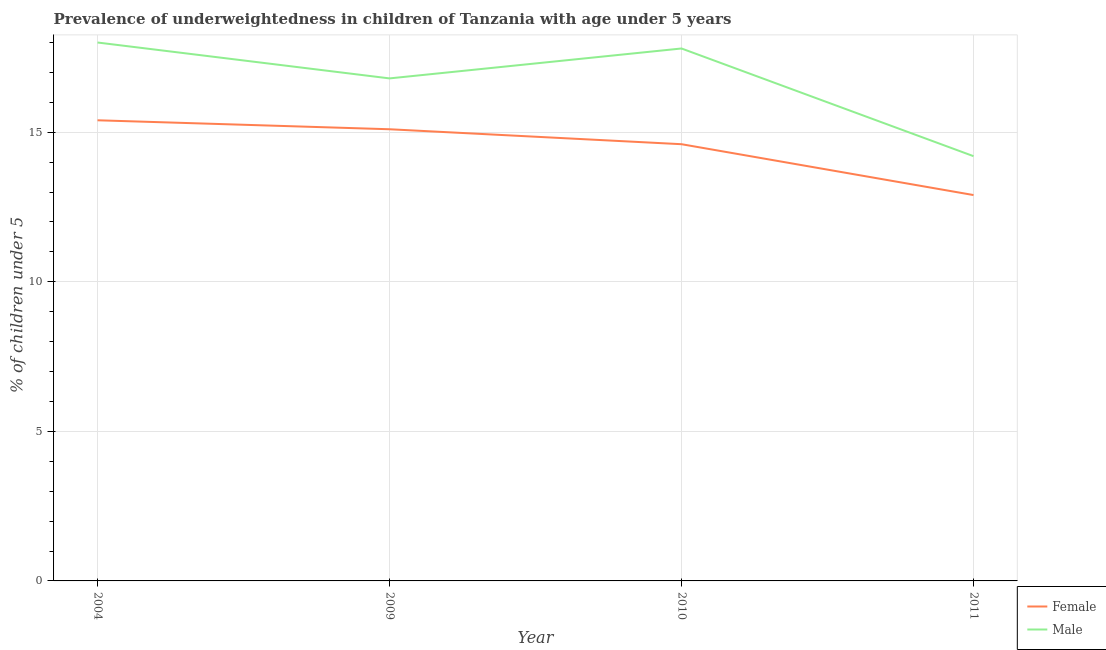How many different coloured lines are there?
Give a very brief answer. 2. What is the percentage of underweighted female children in 2009?
Your answer should be compact. 15.1. Across all years, what is the maximum percentage of underweighted female children?
Ensure brevity in your answer.  15.4. Across all years, what is the minimum percentage of underweighted female children?
Offer a very short reply. 12.9. What is the total percentage of underweighted male children in the graph?
Your answer should be compact. 66.8. What is the difference between the percentage of underweighted male children in 2004 and that in 2011?
Provide a short and direct response. 3.8. What is the difference between the percentage of underweighted male children in 2011 and the percentage of underweighted female children in 2010?
Make the answer very short. -0.4. What is the average percentage of underweighted male children per year?
Make the answer very short. 16.7. In the year 2004, what is the difference between the percentage of underweighted female children and percentage of underweighted male children?
Your response must be concise. -2.6. What is the ratio of the percentage of underweighted male children in 2004 to that in 2010?
Give a very brief answer. 1.01. What is the difference between the highest and the second highest percentage of underweighted female children?
Offer a very short reply. 0.3. What is the difference between the highest and the lowest percentage of underweighted male children?
Ensure brevity in your answer.  3.8. Is the percentage of underweighted female children strictly greater than the percentage of underweighted male children over the years?
Your response must be concise. No. Is the percentage of underweighted male children strictly less than the percentage of underweighted female children over the years?
Give a very brief answer. No. What is the difference between two consecutive major ticks on the Y-axis?
Keep it short and to the point. 5. Does the graph contain grids?
Your answer should be very brief. Yes. Where does the legend appear in the graph?
Ensure brevity in your answer.  Bottom right. How many legend labels are there?
Your response must be concise. 2. How are the legend labels stacked?
Keep it short and to the point. Vertical. What is the title of the graph?
Provide a short and direct response. Prevalence of underweightedness in children of Tanzania with age under 5 years. What is the label or title of the X-axis?
Your answer should be compact. Year. What is the label or title of the Y-axis?
Offer a very short reply.  % of children under 5. What is the  % of children under 5 in Female in 2004?
Offer a terse response. 15.4. What is the  % of children under 5 of Male in 2004?
Ensure brevity in your answer.  18. What is the  % of children under 5 in Female in 2009?
Provide a short and direct response. 15.1. What is the  % of children under 5 of Male in 2009?
Make the answer very short. 16.8. What is the  % of children under 5 in Female in 2010?
Make the answer very short. 14.6. What is the  % of children under 5 of Male in 2010?
Offer a terse response. 17.8. What is the  % of children under 5 in Female in 2011?
Provide a succinct answer. 12.9. What is the  % of children under 5 in Male in 2011?
Offer a terse response. 14.2. Across all years, what is the maximum  % of children under 5 of Female?
Your answer should be very brief. 15.4. Across all years, what is the maximum  % of children under 5 of Male?
Ensure brevity in your answer.  18. Across all years, what is the minimum  % of children under 5 of Female?
Provide a short and direct response. 12.9. Across all years, what is the minimum  % of children under 5 of Male?
Make the answer very short. 14.2. What is the total  % of children under 5 in Female in the graph?
Your response must be concise. 58. What is the total  % of children under 5 of Male in the graph?
Provide a short and direct response. 66.8. What is the difference between the  % of children under 5 in Male in 2004 and that in 2009?
Ensure brevity in your answer.  1.2. What is the difference between the  % of children under 5 of Male in 2004 and that in 2011?
Provide a short and direct response. 3.8. What is the difference between the  % of children under 5 in Female in 2009 and that in 2010?
Provide a succinct answer. 0.5. What is the difference between the  % of children under 5 of Male in 2009 and that in 2010?
Offer a terse response. -1. What is the difference between the  % of children under 5 of Female in 2009 and that in 2011?
Keep it short and to the point. 2.2. What is the difference between the  % of children under 5 of Female in 2004 and the  % of children under 5 of Male in 2011?
Give a very brief answer. 1.2. What is the difference between the  % of children under 5 of Female in 2009 and the  % of children under 5 of Male in 2010?
Your answer should be very brief. -2.7. What is the difference between the  % of children under 5 of Female in 2010 and the  % of children under 5 of Male in 2011?
Your response must be concise. 0.4. In the year 2004, what is the difference between the  % of children under 5 in Female and  % of children under 5 in Male?
Provide a succinct answer. -2.6. In the year 2011, what is the difference between the  % of children under 5 of Female and  % of children under 5 of Male?
Keep it short and to the point. -1.3. What is the ratio of the  % of children under 5 of Female in 2004 to that in 2009?
Provide a succinct answer. 1.02. What is the ratio of the  % of children under 5 of Male in 2004 to that in 2009?
Your answer should be very brief. 1.07. What is the ratio of the  % of children under 5 of Female in 2004 to that in 2010?
Offer a terse response. 1.05. What is the ratio of the  % of children under 5 of Male in 2004 to that in 2010?
Ensure brevity in your answer.  1.01. What is the ratio of the  % of children under 5 in Female in 2004 to that in 2011?
Keep it short and to the point. 1.19. What is the ratio of the  % of children under 5 in Male in 2004 to that in 2011?
Your response must be concise. 1.27. What is the ratio of the  % of children under 5 in Female in 2009 to that in 2010?
Give a very brief answer. 1.03. What is the ratio of the  % of children under 5 of Male in 2009 to that in 2010?
Keep it short and to the point. 0.94. What is the ratio of the  % of children under 5 in Female in 2009 to that in 2011?
Keep it short and to the point. 1.17. What is the ratio of the  % of children under 5 in Male in 2009 to that in 2011?
Your response must be concise. 1.18. What is the ratio of the  % of children under 5 in Female in 2010 to that in 2011?
Keep it short and to the point. 1.13. What is the ratio of the  % of children under 5 of Male in 2010 to that in 2011?
Provide a short and direct response. 1.25. What is the difference between the highest and the lowest  % of children under 5 of Male?
Your response must be concise. 3.8. 